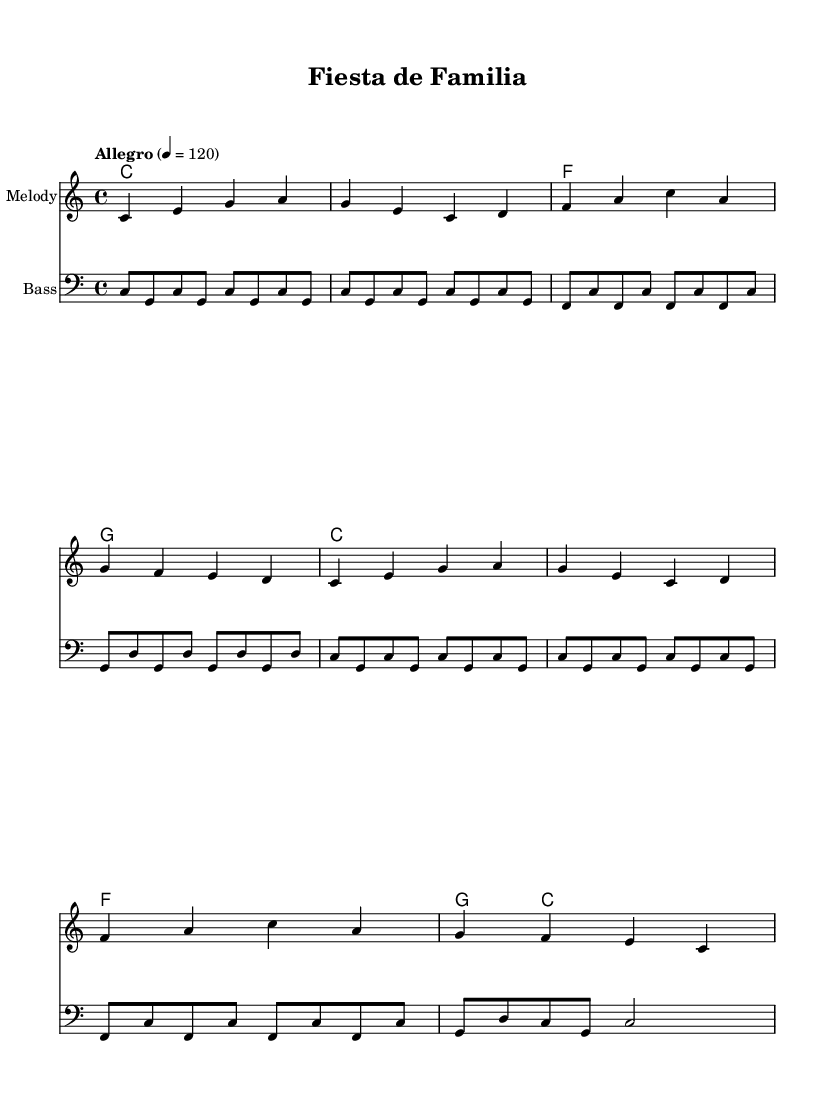What is the key signature of this music? The key signature is C major, which has no sharps or flats indicated. You can identify this by looking for the absence of any sharp or flat symbols at the beginning of the staff.
Answer: C major What is the time signature of this music? The time signature is located at the beginning of the music and is written as 4/4, meaning there are four beats per measure and the quarter note gets one beat.
Answer: 4/4 What is the tempo marking for this piece? The tempo marking is specified in the score as "Allegro," along with the metronome marking of 4 = 120, which indicates a lively and brisk pace.
Answer: Allegro How many measures are in the melody? By counting the distinct groups of notes separated by vertical lines in the melody section, we find that there are eight measures.
Answer: 8 What is the first note of the melody? The first note of the melody is indicated as a C, shown at the start of the staff, which is played as a quarter note.
Answer: C What does the lyric "Celebremos en familia" translate to in English? This lyric translates to "Let's celebrate in family" and indicates the theme of family togetherness in the song.
Answer: Let's celebrate in family What form of music is this piece categorized as? The piece is upbeat Latin pop, characterized by its lively rhythms and focus on family celebrations and milestones reflected in the lyrics and overall style.
Answer: Upbeat Latin pop 